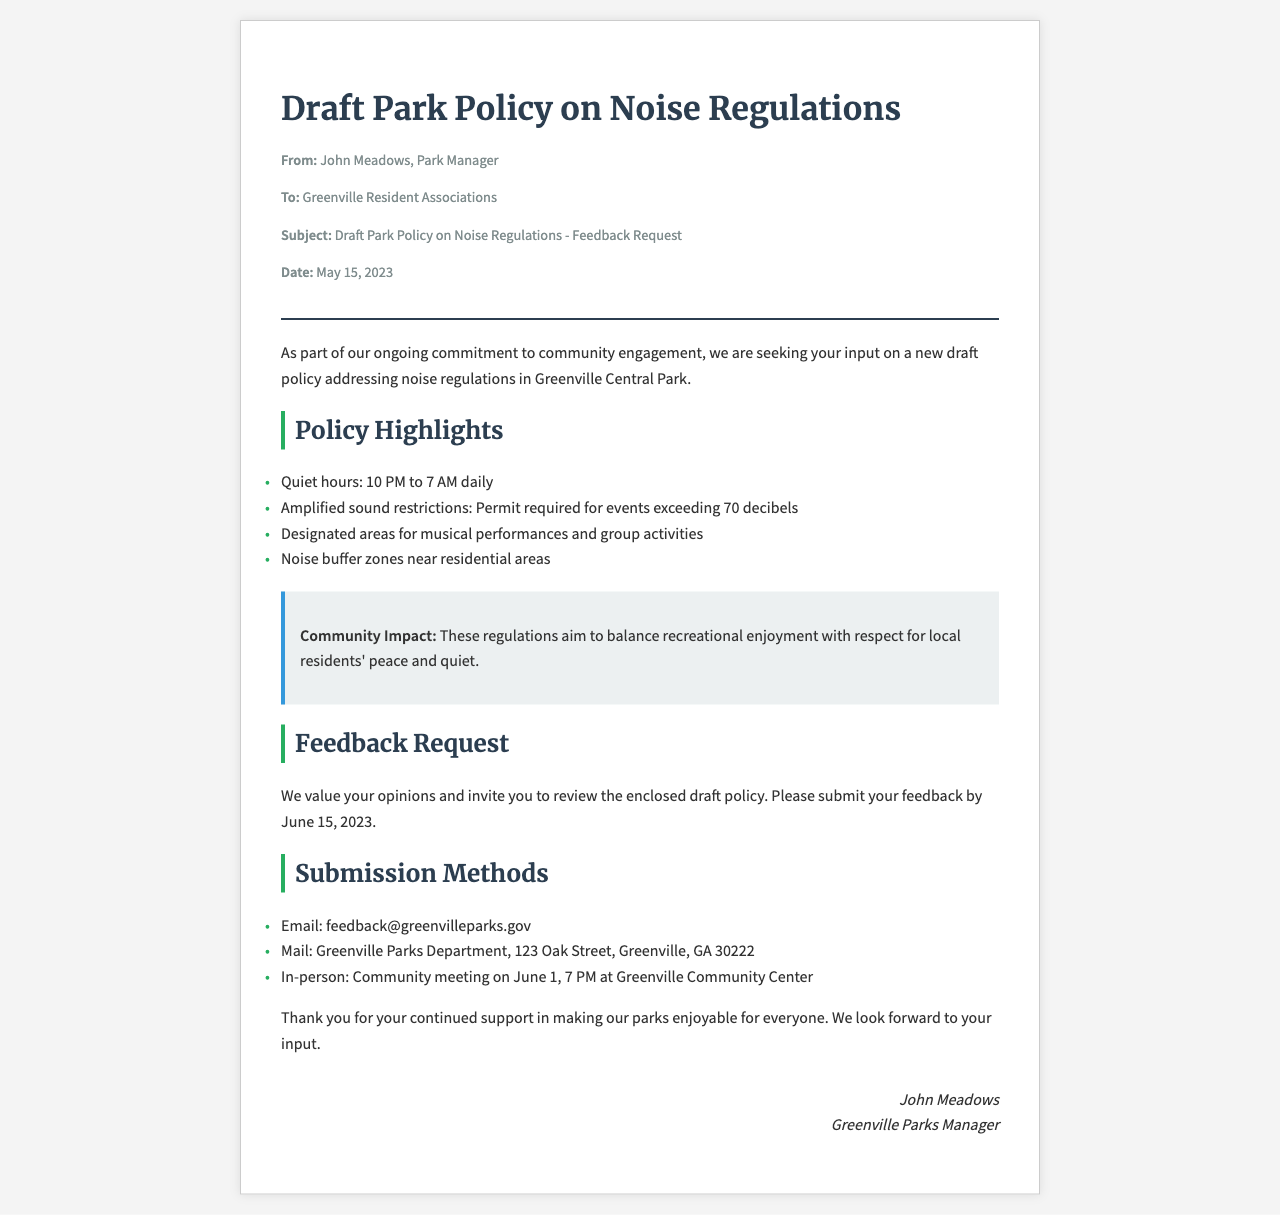What is the draft policy about? The draft policy addresses noise regulations in Greenville Central Park.
Answer: noise regulations Who is the sender of the fax? The sender of the fax is John Meadows, Park Manager.
Answer: John Meadows What are the quiet hours specified? The quiet hours specified in the document are from 10 PM to 7 AM daily.
Answer: 10 PM to 7 AM What is the deadline for feedback submission? The deadline for feedback submission is June 15, 2023.
Answer: June 15, 2023 What is required for events exceeding 70 decibels? A permit is required for events exceeding 70 decibels.
Answer: Permit What is the purpose of the noise regulations? The regulations aim to balance recreational enjoyment with respect for local residents' peace and quiet.
Answer: balance recreational enjoyment What are the submission methods mentioned? The submission methods include email, mail, and in-person feedback.
Answer: email, mail, in-person When is the community meeting scheduled? The community meeting is scheduled for June 1 at 7 PM.
Answer: June 1, 7 PM 